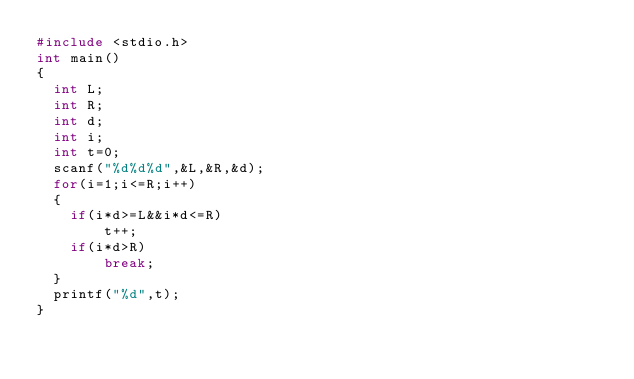Convert code to text. <code><loc_0><loc_0><loc_500><loc_500><_C_>#include <stdio.h>
int main()
{
  int L;
  int R;
  int d;
  int i;
  int t=0;
  scanf("%d%d%d",&L,&R,&d);
  for(i=1;i<=R;i++)
  {
    if(i*d>=L&&i*d<=R)
		t++;
	if(i*d>R)
		break;
  }
  printf("%d",t);
}</code> 